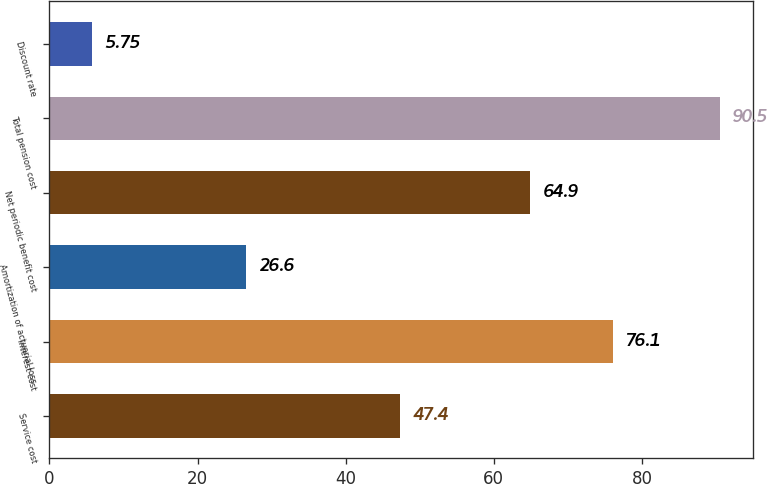<chart> <loc_0><loc_0><loc_500><loc_500><bar_chart><fcel>Service cost<fcel>Interest cost<fcel>Amortization of actuarial loss<fcel>Net periodic benefit cost<fcel>Total pension cost<fcel>Discount rate<nl><fcel>47.4<fcel>76.1<fcel>26.6<fcel>64.9<fcel>90.5<fcel>5.75<nl></chart> 